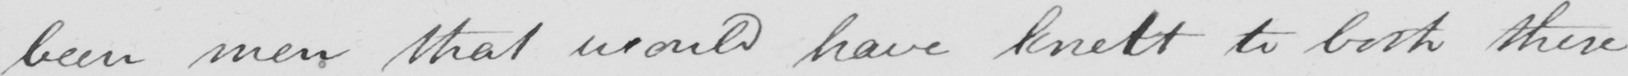Please transcribe the handwritten text in this image. been men that would have knelt to both these 